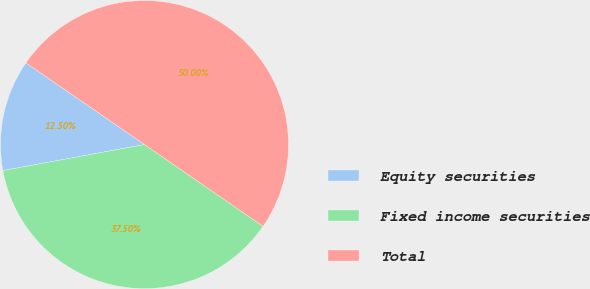Convert chart to OTSL. <chart><loc_0><loc_0><loc_500><loc_500><pie_chart><fcel>Equity securities<fcel>Fixed income securities<fcel>Total<nl><fcel>12.5%<fcel>37.5%<fcel>50.0%<nl></chart> 